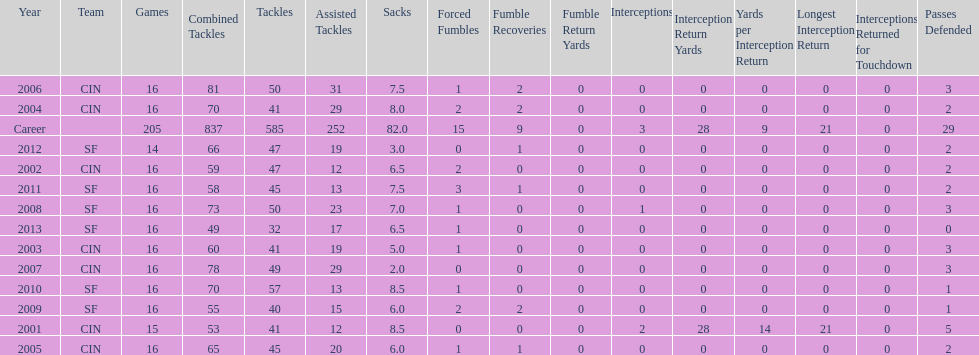How many consecutive seasons has he played sixteen games? 10. 